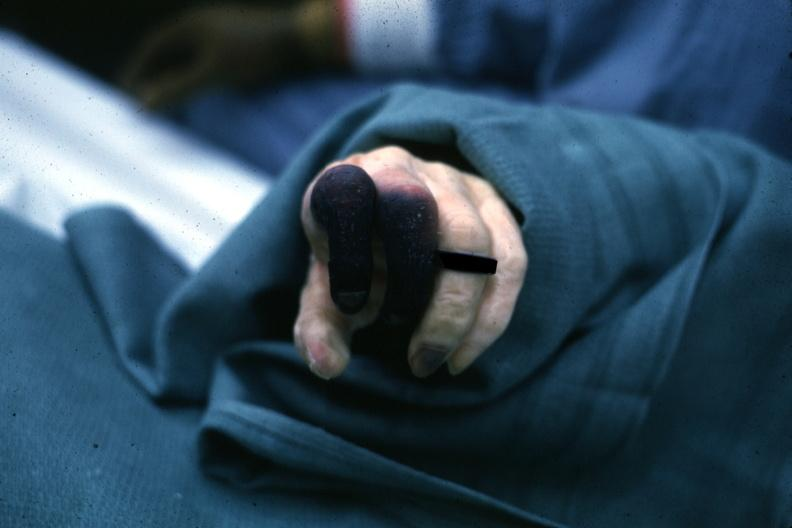what are present?
Answer the question using a single word or phrase. Extremities 